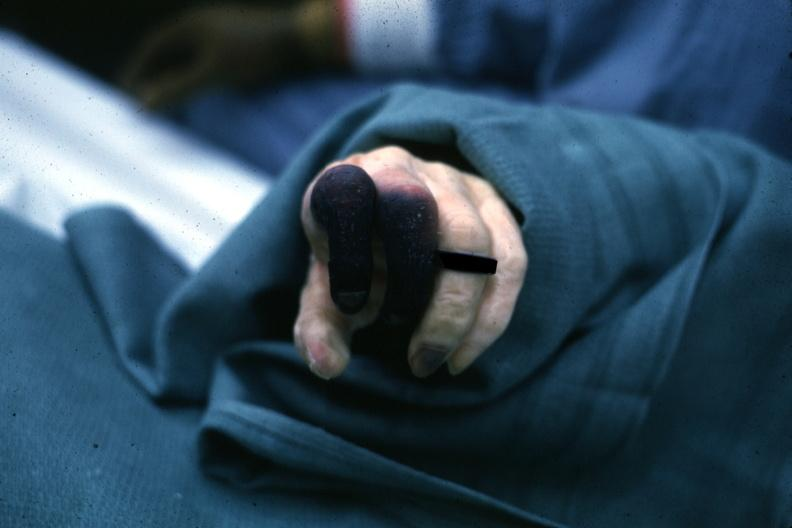what are present?
Answer the question using a single word or phrase. Extremities 